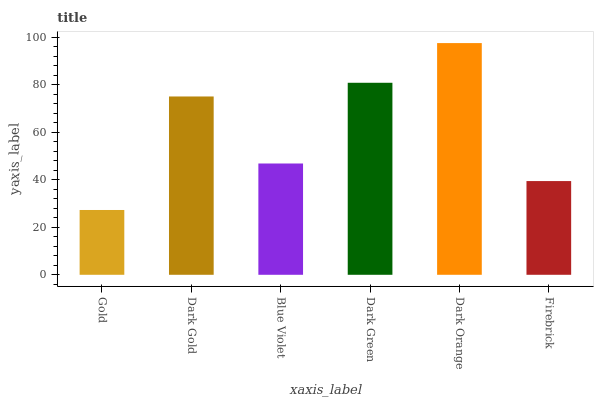Is Gold the minimum?
Answer yes or no. Yes. Is Dark Orange the maximum?
Answer yes or no. Yes. Is Dark Gold the minimum?
Answer yes or no. No. Is Dark Gold the maximum?
Answer yes or no. No. Is Dark Gold greater than Gold?
Answer yes or no. Yes. Is Gold less than Dark Gold?
Answer yes or no. Yes. Is Gold greater than Dark Gold?
Answer yes or no. No. Is Dark Gold less than Gold?
Answer yes or no. No. Is Dark Gold the high median?
Answer yes or no. Yes. Is Blue Violet the low median?
Answer yes or no. Yes. Is Dark Orange the high median?
Answer yes or no. No. Is Dark Gold the low median?
Answer yes or no. No. 